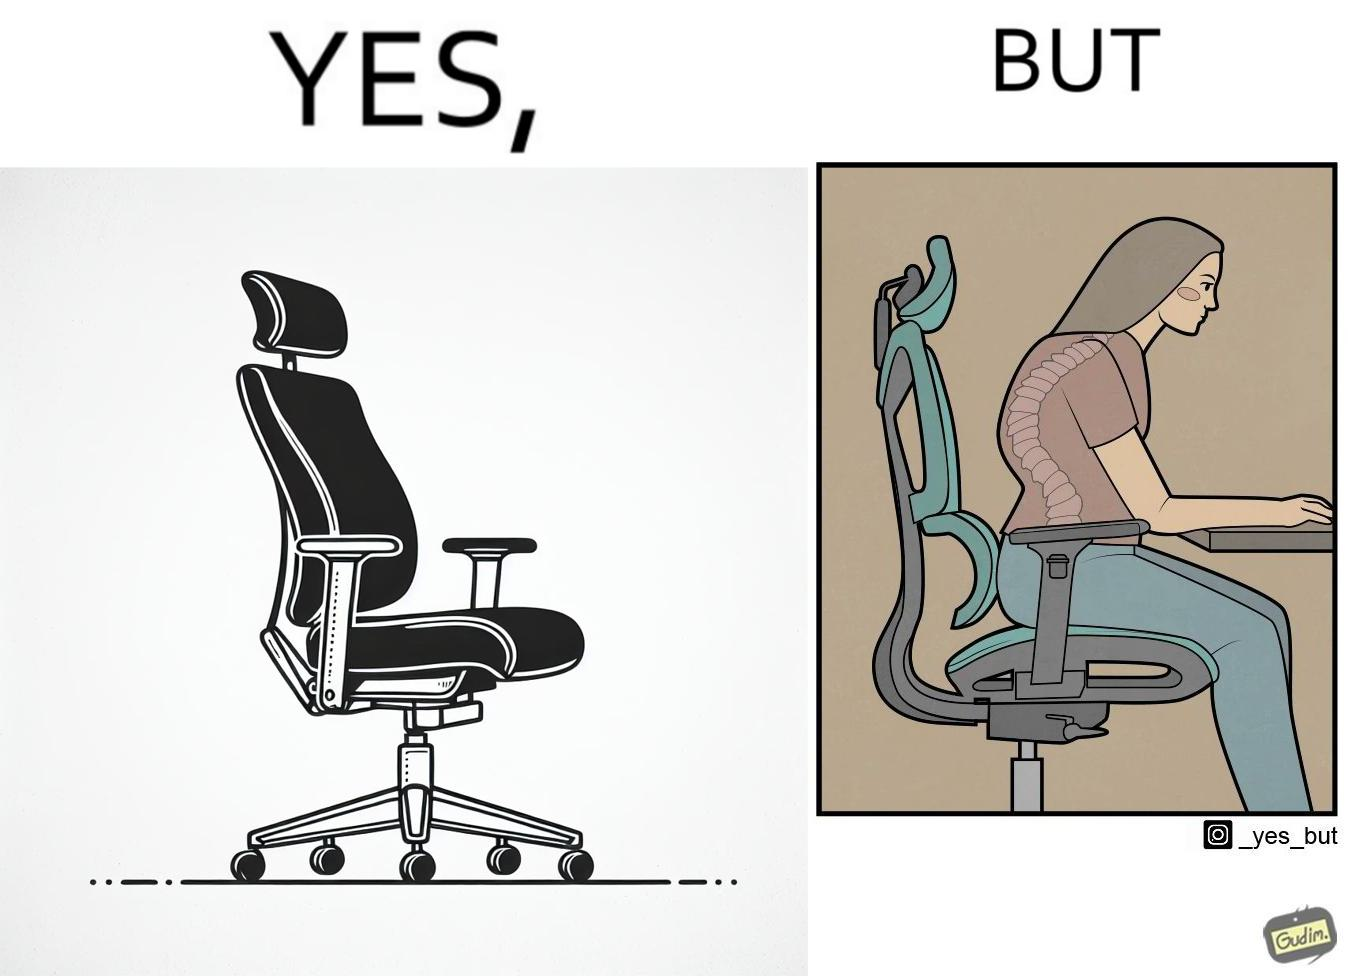Describe the contrast between the left and right parts of this image. In the left part of the image: an ergonomic chair. In the right part of the image: a person sitting on a ergonomic chair with a bent spine. 